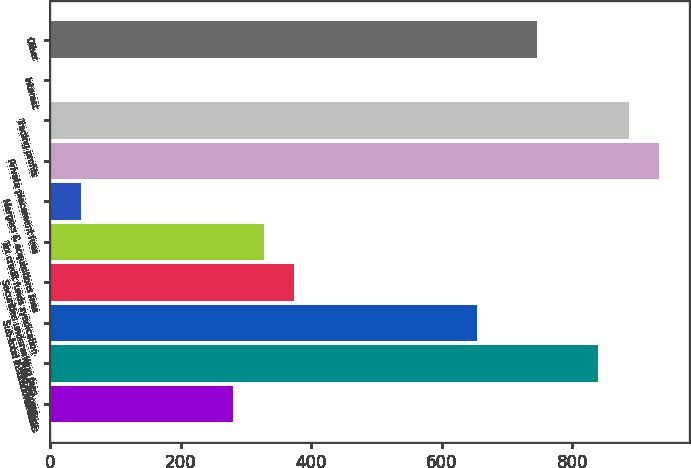<chart> <loc_0><loc_0><loc_500><loc_500><bar_chart><fcel>Equity<fcel>Fixed income<fcel>Sub-total institutional sales<fcel>Securities underwriting fees<fcel>Tax credit funds syndication<fcel>Mergers & acquisitions fees<fcel>Private placement fees<fcel>Trading profits<fcel>Interest<fcel>Other<nl><fcel>280.6<fcel>839.8<fcel>653.4<fcel>373.8<fcel>327.2<fcel>47.6<fcel>933<fcel>886.4<fcel>1<fcel>746.6<nl></chart> 